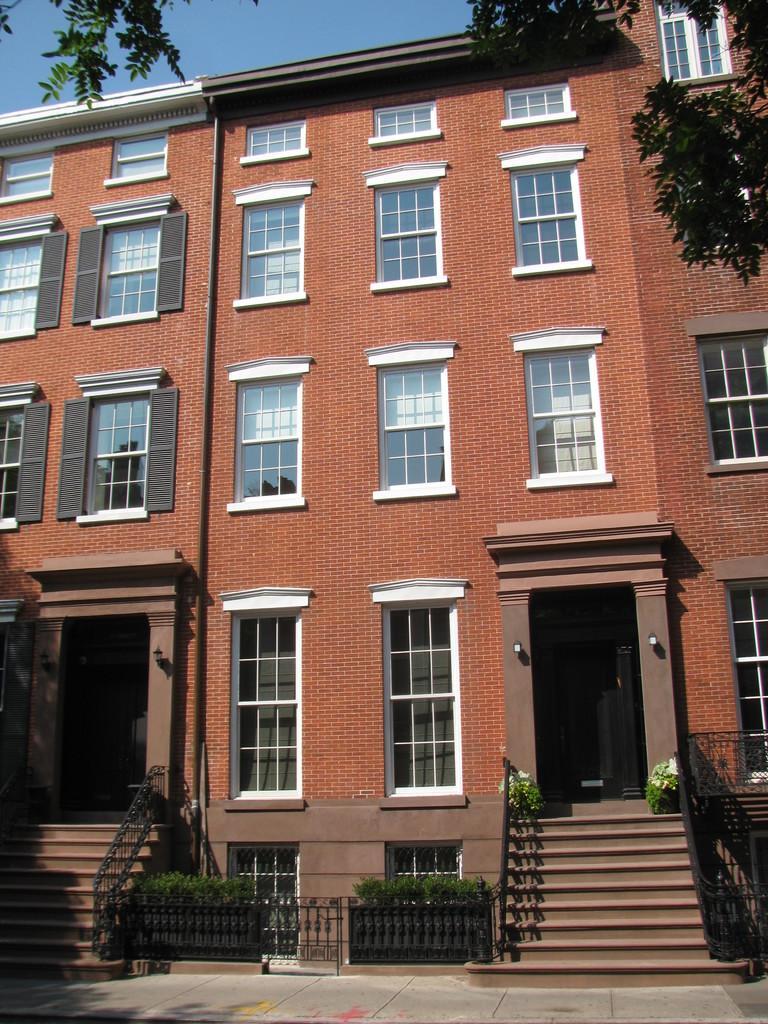Please provide a concise description of this image. In this image I can see the stairs. I can see the building with windows. At the top I can see the sky. 